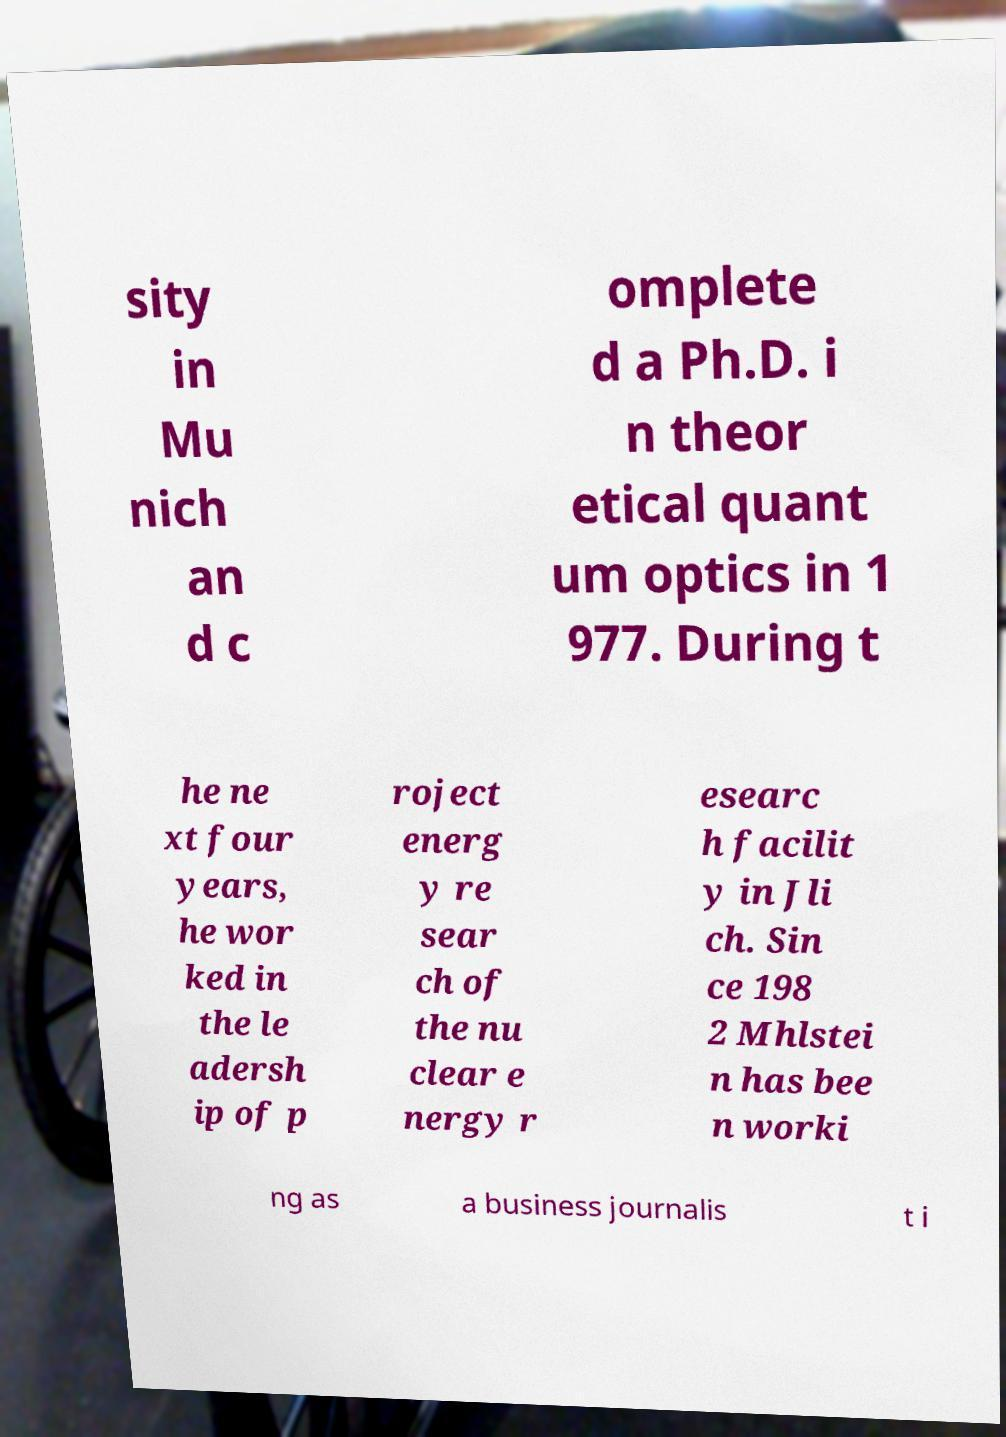I need the written content from this picture converted into text. Can you do that? sity in Mu nich an d c omplete d a Ph.D. i n theor etical quant um optics in 1 977. During t he ne xt four years, he wor ked in the le adersh ip of p roject energ y re sear ch of the nu clear e nergy r esearc h facilit y in Jli ch. Sin ce 198 2 Mhlstei n has bee n worki ng as a business journalis t i 